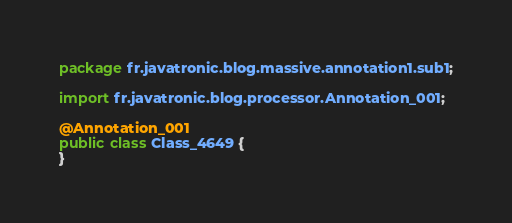<code> <loc_0><loc_0><loc_500><loc_500><_Java_>package fr.javatronic.blog.massive.annotation1.sub1;

import fr.javatronic.blog.processor.Annotation_001;

@Annotation_001
public class Class_4649 {
}
</code> 